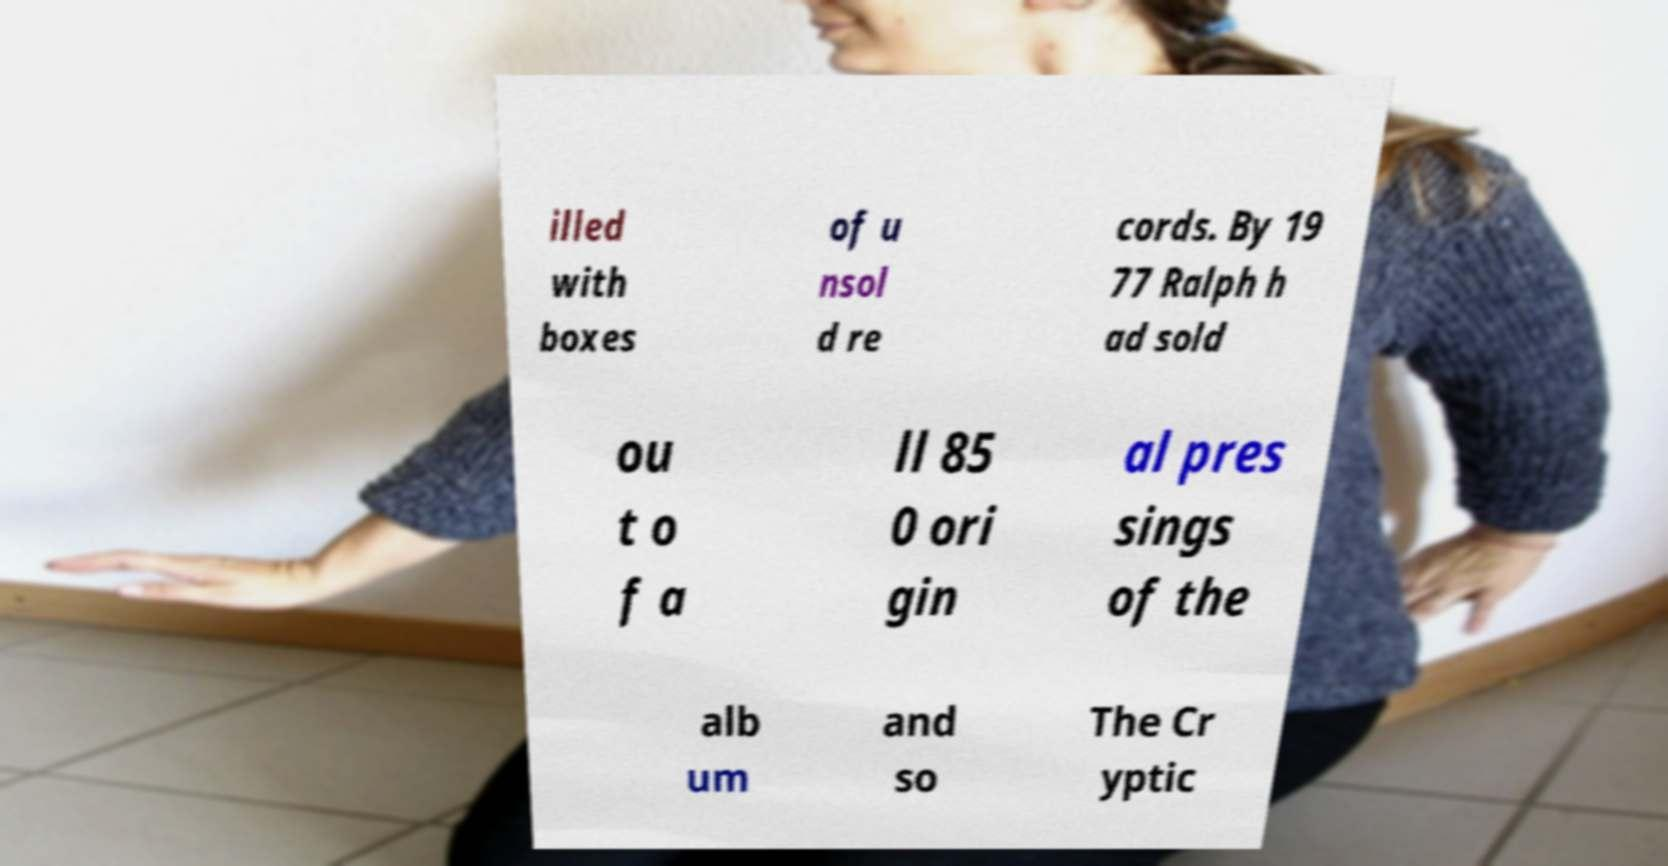What messages or text are displayed in this image? I need them in a readable, typed format. illed with boxes of u nsol d re cords. By 19 77 Ralph h ad sold ou t o f a ll 85 0 ori gin al pres sings of the alb um and so The Cr yptic 